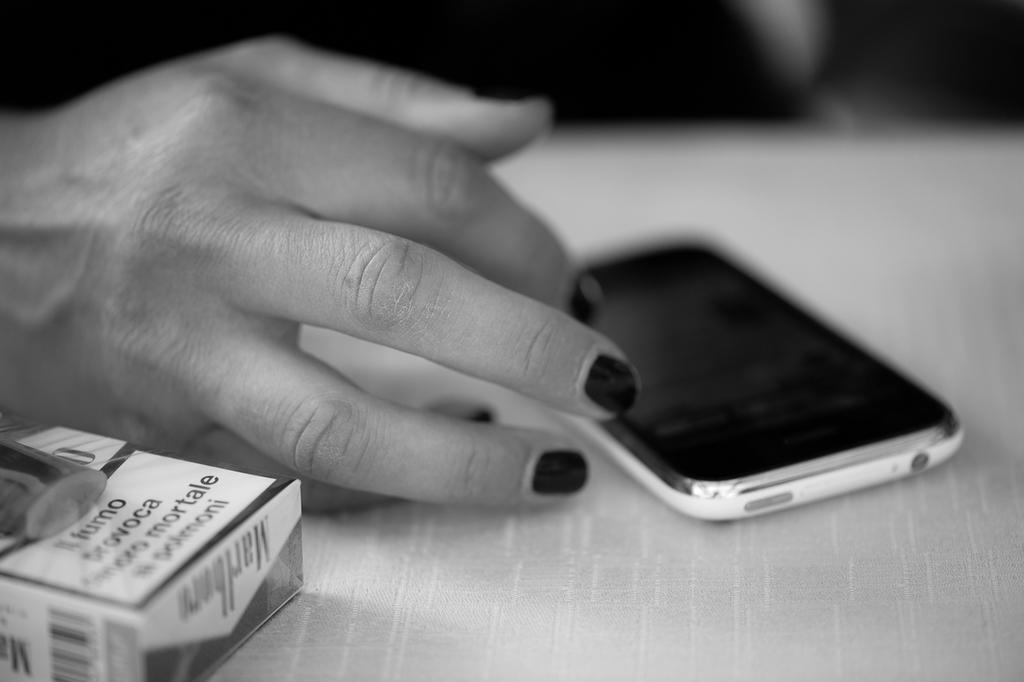What is the color scheme of the image? The image is black and white. What electronic device can be seen in the image? There is a mobile phone in the image. What object is on the table in the image? There is a box on the table in the image. Whose hand is visible in the image? A person's hand is visible in the image. What type of fowl is sitting on the mobile phone in the image? There is no fowl present in the image; it only features a mobile phone, a box, and a person's hand. Who is the creator of the color scheme in the image? The image is black and white, so there is no color to be created. 